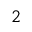Convert formula to latex. <formula><loc_0><loc_0><loc_500><loc_500>^ { 2 }</formula> 